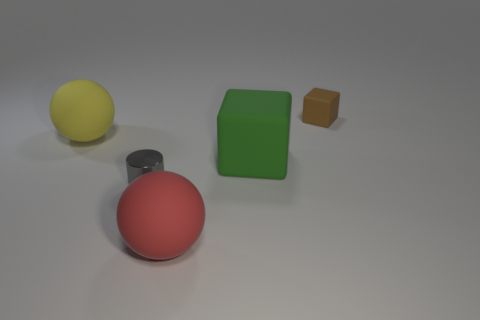Is there a big rubber thing that is to the right of the big ball that is on the right side of the big ball behind the shiny object?
Provide a short and direct response. Yes. What size is the brown object that is made of the same material as the red object?
Provide a short and direct response. Small. Are there any yellow matte balls to the left of the large yellow thing?
Provide a short and direct response. No. Is there a tiny object in front of the tiny object that is on the right side of the big red rubber thing?
Offer a very short reply. Yes. Is the size of the ball that is to the left of the gray object the same as the brown block behind the small gray shiny object?
Your response must be concise. No. What number of big objects are either brown matte things or gray rubber cylinders?
Give a very brief answer. 0. What material is the big ball behind the large thing that is to the right of the red thing?
Offer a very short reply. Rubber. Is there a tiny purple cylinder made of the same material as the big red object?
Give a very brief answer. No. Is the brown block made of the same material as the block that is in front of the tiny cube?
Ensure brevity in your answer.  Yes. What color is the block that is the same size as the red sphere?
Make the answer very short. Green. 